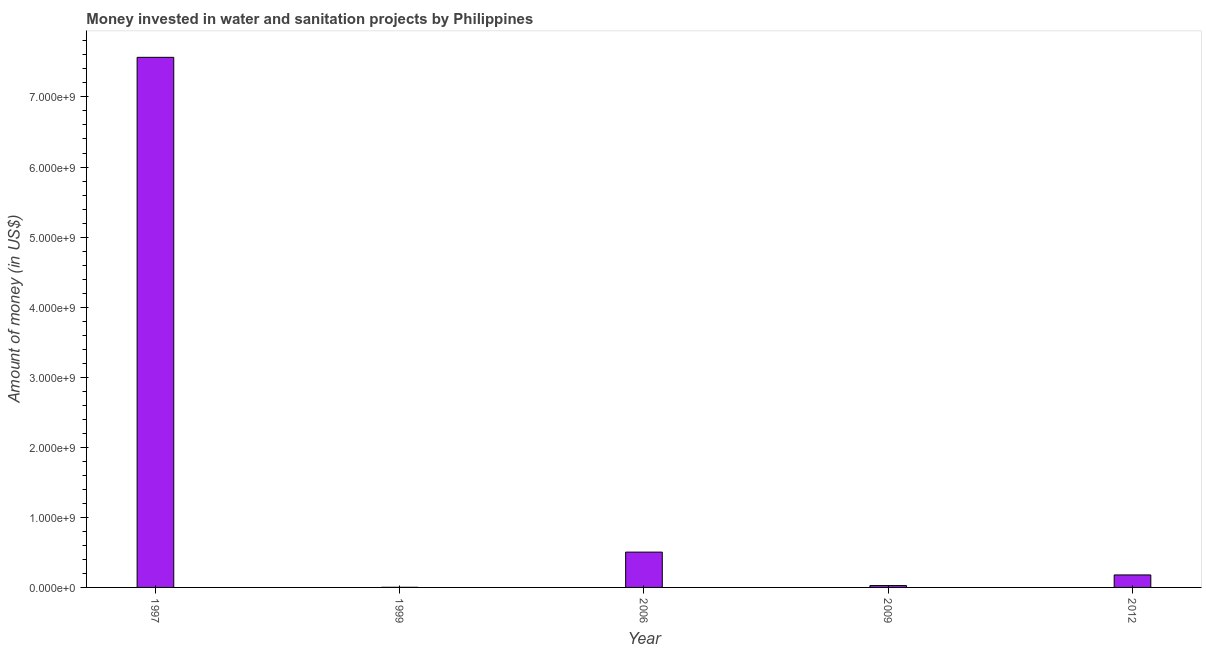What is the title of the graph?
Offer a very short reply. Money invested in water and sanitation projects by Philippines. What is the label or title of the X-axis?
Keep it short and to the point. Year. What is the label or title of the Y-axis?
Keep it short and to the point. Amount of money (in US$). What is the investment in 2012?
Make the answer very short. 1.78e+08. Across all years, what is the maximum investment?
Give a very brief answer. 7.57e+09. Across all years, what is the minimum investment?
Provide a short and direct response. 1.60e+06. What is the sum of the investment?
Make the answer very short. 8.28e+09. What is the difference between the investment in 1999 and 2012?
Your answer should be very brief. -1.77e+08. What is the average investment per year?
Provide a succinct answer. 1.66e+09. What is the median investment?
Ensure brevity in your answer.  1.78e+08. What is the ratio of the investment in 1997 to that in 2006?
Ensure brevity in your answer.  15.01. Is the investment in 1999 less than that in 2012?
Provide a short and direct response. Yes. Is the difference between the investment in 1999 and 2012 greater than the difference between any two years?
Make the answer very short. No. What is the difference between the highest and the second highest investment?
Your answer should be compact. 7.06e+09. Is the sum of the investment in 1999 and 2012 greater than the maximum investment across all years?
Give a very brief answer. No. What is the difference between the highest and the lowest investment?
Your answer should be very brief. 7.56e+09. In how many years, is the investment greater than the average investment taken over all years?
Offer a terse response. 1. Are all the bars in the graph horizontal?
Your answer should be compact. No. How many years are there in the graph?
Your answer should be very brief. 5. Are the values on the major ticks of Y-axis written in scientific E-notation?
Offer a very short reply. Yes. What is the Amount of money (in US$) in 1997?
Your answer should be compact. 7.57e+09. What is the Amount of money (in US$) in 1999?
Offer a very short reply. 1.60e+06. What is the Amount of money (in US$) of 2006?
Offer a very short reply. 5.04e+08. What is the Amount of money (in US$) of 2009?
Give a very brief answer. 2.66e+07. What is the Amount of money (in US$) of 2012?
Provide a short and direct response. 1.78e+08. What is the difference between the Amount of money (in US$) in 1997 and 1999?
Provide a succinct answer. 7.56e+09. What is the difference between the Amount of money (in US$) in 1997 and 2006?
Your answer should be compact. 7.06e+09. What is the difference between the Amount of money (in US$) in 1997 and 2009?
Your answer should be very brief. 7.54e+09. What is the difference between the Amount of money (in US$) in 1997 and 2012?
Provide a succinct answer. 7.39e+09. What is the difference between the Amount of money (in US$) in 1999 and 2006?
Ensure brevity in your answer.  -5.02e+08. What is the difference between the Amount of money (in US$) in 1999 and 2009?
Ensure brevity in your answer.  -2.50e+07. What is the difference between the Amount of money (in US$) in 1999 and 2012?
Your response must be concise. -1.77e+08. What is the difference between the Amount of money (in US$) in 2006 and 2009?
Make the answer very short. 4.77e+08. What is the difference between the Amount of money (in US$) in 2006 and 2012?
Keep it short and to the point. 3.26e+08. What is the difference between the Amount of money (in US$) in 2009 and 2012?
Provide a succinct answer. -1.52e+08. What is the ratio of the Amount of money (in US$) in 1997 to that in 1999?
Give a very brief answer. 4728.5. What is the ratio of the Amount of money (in US$) in 1997 to that in 2006?
Your answer should be very brief. 15.01. What is the ratio of the Amount of money (in US$) in 1997 to that in 2009?
Offer a terse response. 284.42. What is the ratio of the Amount of money (in US$) in 1997 to that in 2012?
Keep it short and to the point. 42.43. What is the ratio of the Amount of money (in US$) in 1999 to that in 2006?
Keep it short and to the point. 0. What is the ratio of the Amount of money (in US$) in 1999 to that in 2012?
Your response must be concise. 0.01. What is the ratio of the Amount of money (in US$) in 2006 to that in 2009?
Give a very brief answer. 18.94. What is the ratio of the Amount of money (in US$) in 2006 to that in 2012?
Ensure brevity in your answer.  2.83. What is the ratio of the Amount of money (in US$) in 2009 to that in 2012?
Provide a short and direct response. 0.15. 